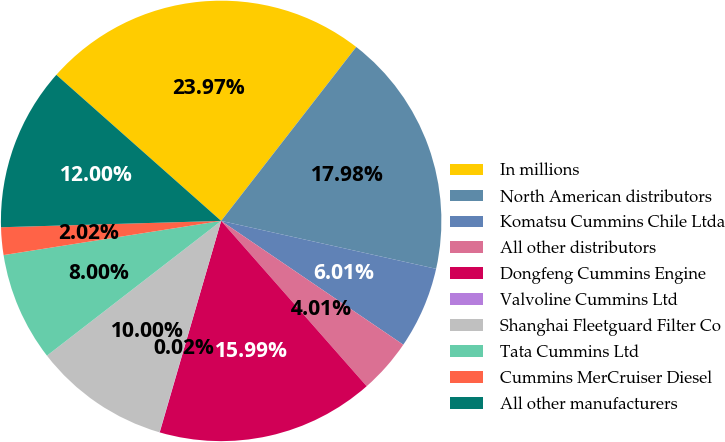<chart> <loc_0><loc_0><loc_500><loc_500><pie_chart><fcel>In millions<fcel>North American distributors<fcel>Komatsu Cummins Chile Ltda<fcel>All other distributors<fcel>Dongfeng Cummins Engine<fcel>Valvoline Cummins Ltd<fcel>Shanghai Fleetguard Filter Co<fcel>Tata Cummins Ltd<fcel>Cummins MerCruiser Diesel<fcel>All other manufacturers<nl><fcel>23.97%<fcel>17.98%<fcel>6.01%<fcel>4.01%<fcel>15.99%<fcel>0.02%<fcel>10.0%<fcel>8.0%<fcel>2.02%<fcel>12.0%<nl></chart> 